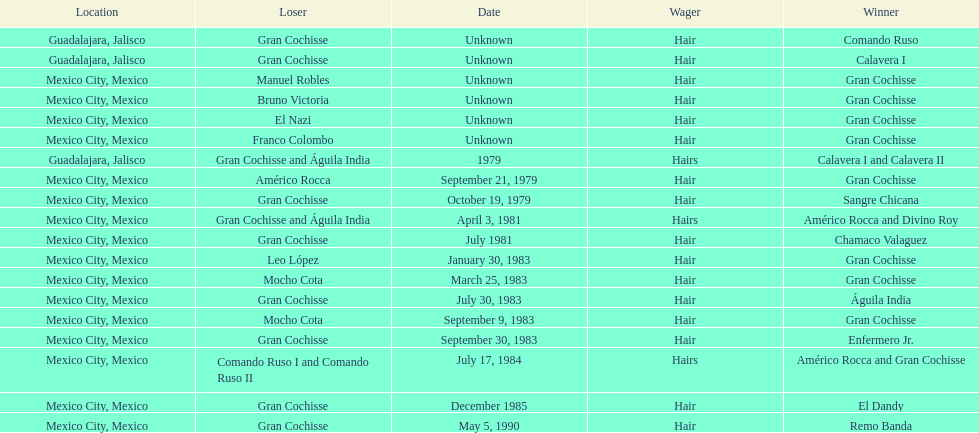How many times has the wager been hair? 16. 